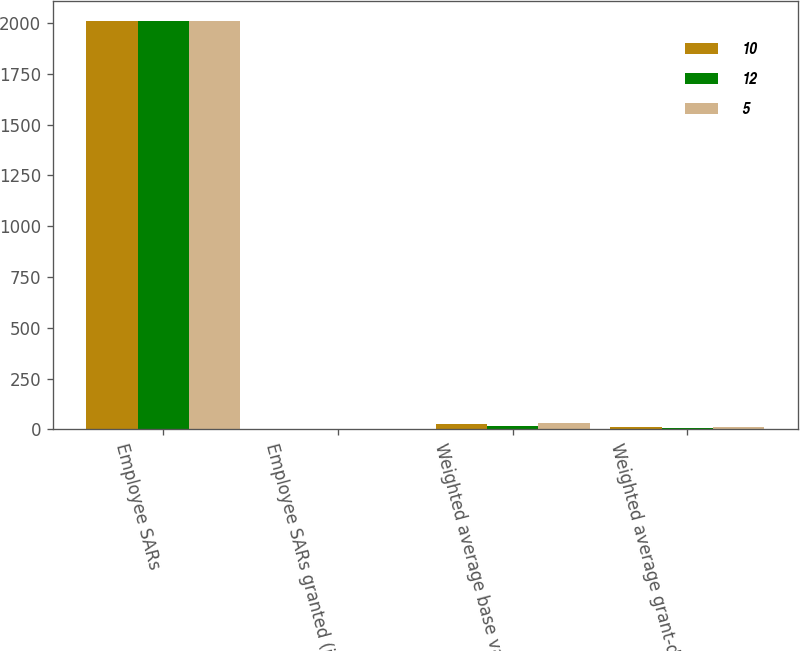<chart> <loc_0><loc_0><loc_500><loc_500><stacked_bar_chart><ecel><fcel>Employee SARs<fcel>Employee SARs granted (in<fcel>Weighted average base value<fcel>Weighted average grant-date<nl><fcel>10<fcel>2010<fcel>1.1<fcel>27<fcel>10<nl><fcel>12<fcel>2009<fcel>0.5<fcel>15<fcel>5<nl><fcel>5<fcel>2008<fcel>2.7<fcel>33<fcel>12<nl></chart> 